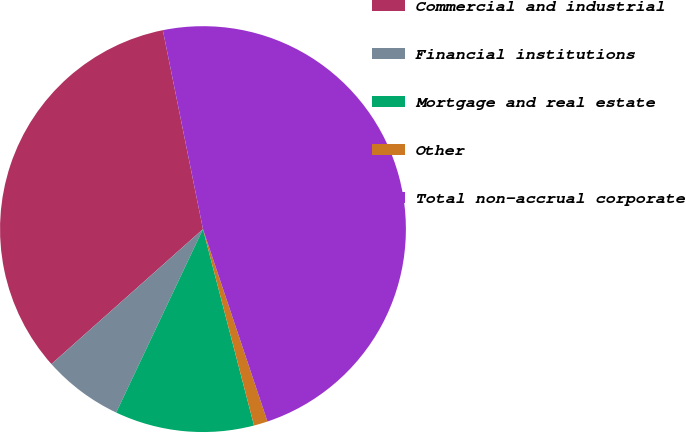<chart> <loc_0><loc_0><loc_500><loc_500><pie_chart><fcel>Commercial and industrial<fcel>Financial institutions<fcel>Mortgage and real estate<fcel>Other<fcel>Total non-accrual corporate<nl><fcel>33.41%<fcel>6.39%<fcel>11.08%<fcel>1.1%<fcel>48.02%<nl></chart> 